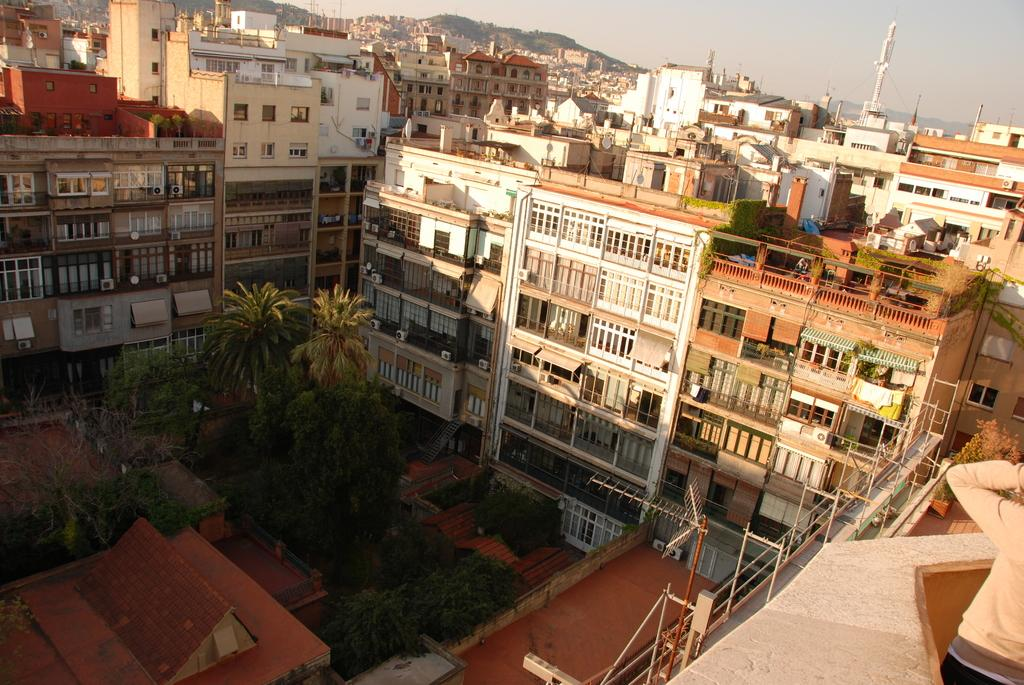What type of structures can be seen in the image? There are buildings and a tower in the image. What natural elements are present in the image? There are trees in the image. What man-made objects can be seen in the image? There are poles in the image. What additional feature can be observed in the image? There is a shadow in the image. Are there any people present in the image? Yes, there is a person standing in the image. What type of feather can be seen falling from the tower in the image? There is no feather falling from the tower in the image; it only features buildings, trees, poles, a shadow, and a person. What connection can be made between the person and the tower in the image? There is no information provided about any connection between the person and the tower in the image. 